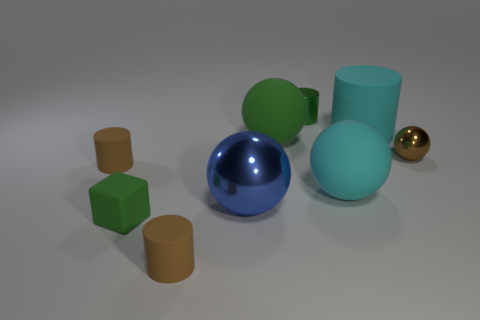Subtract all small brown spheres. How many spheres are left? 3 Subtract all brown blocks. How many brown cylinders are left? 2 Subtract 3 cylinders. How many cylinders are left? 1 Subtract all brown spheres. How many spheres are left? 3 Subtract all cylinders. How many objects are left? 5 Subtract 0 cyan cubes. How many objects are left? 9 Subtract all green cylinders. Subtract all purple balls. How many cylinders are left? 3 Subtract all large green rubber things. Subtract all matte things. How many objects are left? 2 Add 4 tiny brown cylinders. How many tiny brown cylinders are left? 6 Add 3 tiny purple metallic balls. How many tiny purple metallic balls exist? 3 